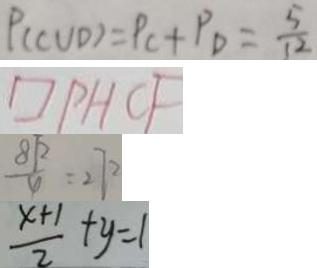Convert formula to latex. <formula><loc_0><loc_0><loc_500><loc_500>P ( C U D ) = P C + P _ { D } = \frac { 5 } { 1 2 } 
 \square P H C F 
 \frac { 8 \sqrt { 2 } } { 4 } = 2 7 2 
 \frac { x + 1 } { 2 } + y = 1</formula> 